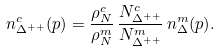Convert formula to latex. <formula><loc_0><loc_0><loc_500><loc_500>n _ { \Delta ^ { + + } } ^ { c } ( p ) = \frac { \rho _ { N } ^ { c } } { \rho _ { N } ^ { m } } \, \frac { N _ { \Delta ^ { + + } } ^ { c } } { N _ { \Delta ^ { + + } } ^ { m } } \, n _ { \Delta } ^ { m } ( p ) .</formula> 